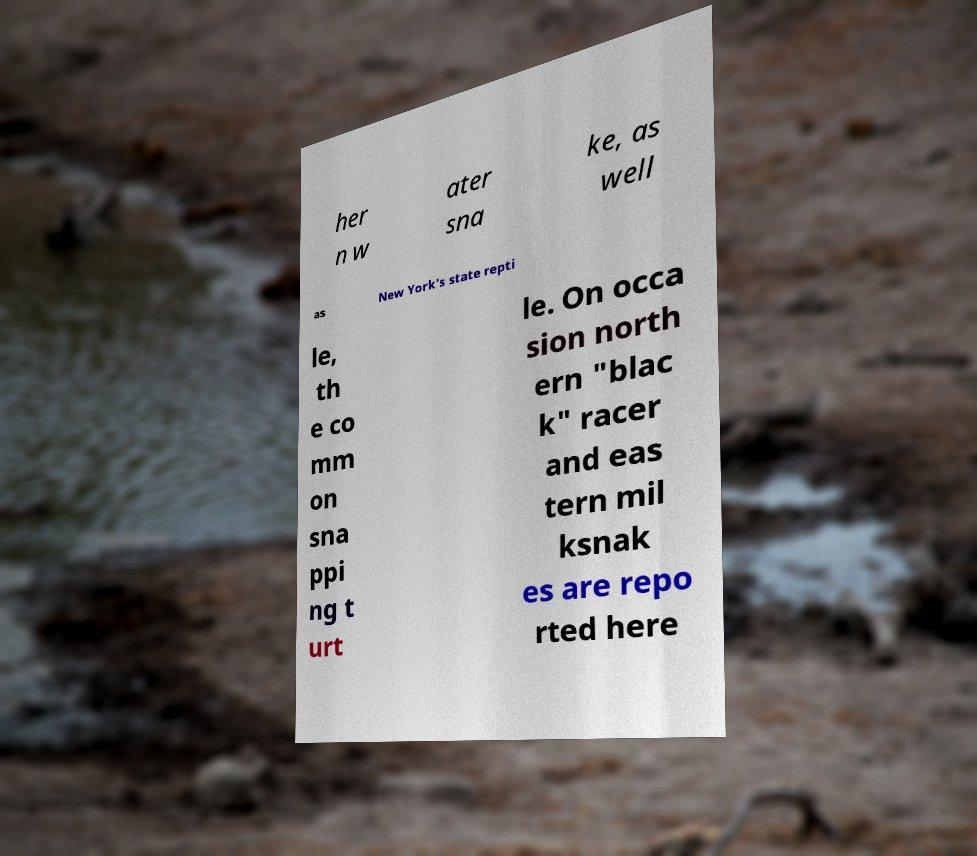Please identify and transcribe the text found in this image. her n w ater sna ke, as well as New York's state repti le, th e co mm on sna ppi ng t urt le. On occa sion north ern "blac k" racer and eas tern mil ksnak es are repo rted here 